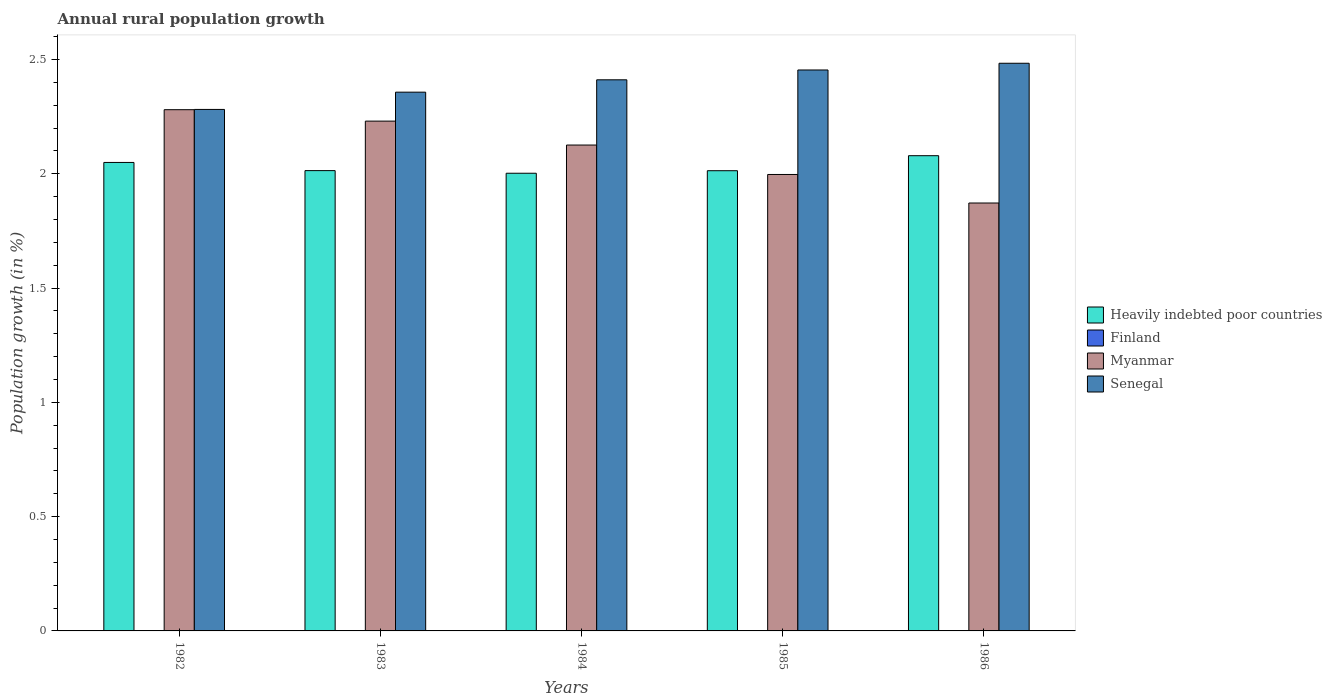How many different coloured bars are there?
Offer a terse response. 3. How many groups of bars are there?
Provide a short and direct response. 5. Are the number of bars per tick equal to the number of legend labels?
Provide a succinct answer. No. How many bars are there on the 2nd tick from the left?
Ensure brevity in your answer.  3. How many bars are there on the 1st tick from the right?
Make the answer very short. 3. What is the label of the 3rd group of bars from the left?
Your answer should be compact. 1984. In how many cases, is the number of bars for a given year not equal to the number of legend labels?
Make the answer very short. 5. What is the percentage of rural population growth in Heavily indebted poor countries in 1983?
Keep it short and to the point. 2.01. Across all years, what is the maximum percentage of rural population growth in Senegal?
Your response must be concise. 2.48. Across all years, what is the minimum percentage of rural population growth in Senegal?
Provide a short and direct response. 2.28. In which year was the percentage of rural population growth in Myanmar maximum?
Make the answer very short. 1982. What is the total percentage of rural population growth in Heavily indebted poor countries in the graph?
Your answer should be very brief. 10.16. What is the difference between the percentage of rural population growth in Myanmar in 1982 and that in 1984?
Keep it short and to the point. 0.15. What is the difference between the percentage of rural population growth in Senegal in 1982 and the percentage of rural population growth in Finland in 1983?
Offer a terse response. 2.28. What is the average percentage of rural population growth in Heavily indebted poor countries per year?
Your answer should be compact. 2.03. In the year 1983, what is the difference between the percentage of rural population growth in Heavily indebted poor countries and percentage of rural population growth in Senegal?
Make the answer very short. -0.34. What is the ratio of the percentage of rural population growth in Myanmar in 1984 to that in 1985?
Keep it short and to the point. 1.06. Is the percentage of rural population growth in Heavily indebted poor countries in 1983 less than that in 1985?
Your answer should be compact. No. Is the difference between the percentage of rural population growth in Heavily indebted poor countries in 1982 and 1984 greater than the difference between the percentage of rural population growth in Senegal in 1982 and 1984?
Ensure brevity in your answer.  Yes. What is the difference between the highest and the second highest percentage of rural population growth in Heavily indebted poor countries?
Your answer should be compact. 0.03. What is the difference between the highest and the lowest percentage of rural population growth in Myanmar?
Your answer should be compact. 0.41. Is the sum of the percentage of rural population growth in Myanmar in 1982 and 1983 greater than the maximum percentage of rural population growth in Heavily indebted poor countries across all years?
Ensure brevity in your answer.  Yes. Is it the case that in every year, the sum of the percentage of rural population growth in Heavily indebted poor countries and percentage of rural population growth in Senegal is greater than the sum of percentage of rural population growth in Finland and percentage of rural population growth in Myanmar?
Keep it short and to the point. No. How many bars are there?
Offer a terse response. 15. Are all the bars in the graph horizontal?
Provide a succinct answer. No. Does the graph contain grids?
Make the answer very short. No. Where does the legend appear in the graph?
Your response must be concise. Center right. How are the legend labels stacked?
Make the answer very short. Vertical. What is the title of the graph?
Your answer should be very brief. Annual rural population growth. Does "Sweden" appear as one of the legend labels in the graph?
Provide a short and direct response. No. What is the label or title of the Y-axis?
Your response must be concise. Population growth (in %). What is the Population growth (in %) of Heavily indebted poor countries in 1982?
Give a very brief answer. 2.05. What is the Population growth (in %) of Myanmar in 1982?
Keep it short and to the point. 2.28. What is the Population growth (in %) of Senegal in 1982?
Keep it short and to the point. 2.28. What is the Population growth (in %) of Heavily indebted poor countries in 1983?
Ensure brevity in your answer.  2.01. What is the Population growth (in %) in Myanmar in 1983?
Provide a short and direct response. 2.23. What is the Population growth (in %) in Senegal in 1983?
Make the answer very short. 2.36. What is the Population growth (in %) of Heavily indebted poor countries in 1984?
Provide a short and direct response. 2. What is the Population growth (in %) of Finland in 1984?
Give a very brief answer. 0. What is the Population growth (in %) in Myanmar in 1984?
Your answer should be very brief. 2.13. What is the Population growth (in %) in Senegal in 1984?
Offer a terse response. 2.41. What is the Population growth (in %) in Heavily indebted poor countries in 1985?
Provide a short and direct response. 2.01. What is the Population growth (in %) of Myanmar in 1985?
Keep it short and to the point. 2. What is the Population growth (in %) in Senegal in 1985?
Your answer should be compact. 2.45. What is the Population growth (in %) of Heavily indebted poor countries in 1986?
Provide a short and direct response. 2.08. What is the Population growth (in %) in Myanmar in 1986?
Offer a terse response. 1.87. What is the Population growth (in %) of Senegal in 1986?
Your response must be concise. 2.48. Across all years, what is the maximum Population growth (in %) in Heavily indebted poor countries?
Keep it short and to the point. 2.08. Across all years, what is the maximum Population growth (in %) in Myanmar?
Provide a short and direct response. 2.28. Across all years, what is the maximum Population growth (in %) of Senegal?
Your response must be concise. 2.48. Across all years, what is the minimum Population growth (in %) in Heavily indebted poor countries?
Offer a very short reply. 2. Across all years, what is the minimum Population growth (in %) of Myanmar?
Offer a terse response. 1.87. Across all years, what is the minimum Population growth (in %) of Senegal?
Your answer should be very brief. 2.28. What is the total Population growth (in %) of Heavily indebted poor countries in the graph?
Your answer should be compact. 10.16. What is the total Population growth (in %) of Myanmar in the graph?
Ensure brevity in your answer.  10.51. What is the total Population growth (in %) of Senegal in the graph?
Your answer should be very brief. 11.99. What is the difference between the Population growth (in %) in Heavily indebted poor countries in 1982 and that in 1983?
Offer a very short reply. 0.04. What is the difference between the Population growth (in %) in Myanmar in 1982 and that in 1983?
Offer a very short reply. 0.05. What is the difference between the Population growth (in %) in Senegal in 1982 and that in 1983?
Your answer should be very brief. -0.08. What is the difference between the Population growth (in %) in Heavily indebted poor countries in 1982 and that in 1984?
Give a very brief answer. 0.05. What is the difference between the Population growth (in %) of Myanmar in 1982 and that in 1984?
Provide a short and direct response. 0.15. What is the difference between the Population growth (in %) in Senegal in 1982 and that in 1984?
Your answer should be very brief. -0.13. What is the difference between the Population growth (in %) in Heavily indebted poor countries in 1982 and that in 1985?
Your answer should be very brief. 0.04. What is the difference between the Population growth (in %) of Myanmar in 1982 and that in 1985?
Provide a succinct answer. 0.28. What is the difference between the Population growth (in %) of Senegal in 1982 and that in 1985?
Your answer should be very brief. -0.17. What is the difference between the Population growth (in %) in Heavily indebted poor countries in 1982 and that in 1986?
Ensure brevity in your answer.  -0.03. What is the difference between the Population growth (in %) of Myanmar in 1982 and that in 1986?
Your response must be concise. 0.41. What is the difference between the Population growth (in %) of Senegal in 1982 and that in 1986?
Your answer should be very brief. -0.2. What is the difference between the Population growth (in %) in Heavily indebted poor countries in 1983 and that in 1984?
Your answer should be compact. 0.01. What is the difference between the Population growth (in %) in Myanmar in 1983 and that in 1984?
Provide a short and direct response. 0.1. What is the difference between the Population growth (in %) in Senegal in 1983 and that in 1984?
Your answer should be compact. -0.05. What is the difference between the Population growth (in %) of Heavily indebted poor countries in 1983 and that in 1985?
Give a very brief answer. 0. What is the difference between the Population growth (in %) in Myanmar in 1983 and that in 1985?
Keep it short and to the point. 0.23. What is the difference between the Population growth (in %) of Senegal in 1983 and that in 1985?
Give a very brief answer. -0.1. What is the difference between the Population growth (in %) of Heavily indebted poor countries in 1983 and that in 1986?
Make the answer very short. -0.07. What is the difference between the Population growth (in %) of Myanmar in 1983 and that in 1986?
Offer a terse response. 0.36. What is the difference between the Population growth (in %) in Senegal in 1983 and that in 1986?
Provide a short and direct response. -0.13. What is the difference between the Population growth (in %) of Heavily indebted poor countries in 1984 and that in 1985?
Provide a short and direct response. -0.01. What is the difference between the Population growth (in %) in Myanmar in 1984 and that in 1985?
Ensure brevity in your answer.  0.13. What is the difference between the Population growth (in %) of Senegal in 1984 and that in 1985?
Give a very brief answer. -0.04. What is the difference between the Population growth (in %) in Heavily indebted poor countries in 1984 and that in 1986?
Provide a short and direct response. -0.08. What is the difference between the Population growth (in %) in Myanmar in 1984 and that in 1986?
Offer a very short reply. 0.25. What is the difference between the Population growth (in %) of Senegal in 1984 and that in 1986?
Ensure brevity in your answer.  -0.07. What is the difference between the Population growth (in %) in Heavily indebted poor countries in 1985 and that in 1986?
Provide a short and direct response. -0.07. What is the difference between the Population growth (in %) of Myanmar in 1985 and that in 1986?
Provide a short and direct response. 0.12. What is the difference between the Population growth (in %) of Senegal in 1985 and that in 1986?
Your response must be concise. -0.03. What is the difference between the Population growth (in %) in Heavily indebted poor countries in 1982 and the Population growth (in %) in Myanmar in 1983?
Make the answer very short. -0.18. What is the difference between the Population growth (in %) in Heavily indebted poor countries in 1982 and the Population growth (in %) in Senegal in 1983?
Offer a terse response. -0.31. What is the difference between the Population growth (in %) in Myanmar in 1982 and the Population growth (in %) in Senegal in 1983?
Your answer should be compact. -0.08. What is the difference between the Population growth (in %) in Heavily indebted poor countries in 1982 and the Population growth (in %) in Myanmar in 1984?
Provide a succinct answer. -0.08. What is the difference between the Population growth (in %) in Heavily indebted poor countries in 1982 and the Population growth (in %) in Senegal in 1984?
Your answer should be very brief. -0.36. What is the difference between the Population growth (in %) in Myanmar in 1982 and the Population growth (in %) in Senegal in 1984?
Offer a terse response. -0.13. What is the difference between the Population growth (in %) of Heavily indebted poor countries in 1982 and the Population growth (in %) of Myanmar in 1985?
Make the answer very short. 0.05. What is the difference between the Population growth (in %) of Heavily indebted poor countries in 1982 and the Population growth (in %) of Senegal in 1985?
Give a very brief answer. -0.4. What is the difference between the Population growth (in %) in Myanmar in 1982 and the Population growth (in %) in Senegal in 1985?
Give a very brief answer. -0.17. What is the difference between the Population growth (in %) of Heavily indebted poor countries in 1982 and the Population growth (in %) of Myanmar in 1986?
Your answer should be very brief. 0.18. What is the difference between the Population growth (in %) in Heavily indebted poor countries in 1982 and the Population growth (in %) in Senegal in 1986?
Provide a succinct answer. -0.43. What is the difference between the Population growth (in %) of Myanmar in 1982 and the Population growth (in %) of Senegal in 1986?
Offer a very short reply. -0.2. What is the difference between the Population growth (in %) of Heavily indebted poor countries in 1983 and the Population growth (in %) of Myanmar in 1984?
Provide a succinct answer. -0.11. What is the difference between the Population growth (in %) of Heavily indebted poor countries in 1983 and the Population growth (in %) of Senegal in 1984?
Make the answer very short. -0.4. What is the difference between the Population growth (in %) of Myanmar in 1983 and the Population growth (in %) of Senegal in 1984?
Keep it short and to the point. -0.18. What is the difference between the Population growth (in %) in Heavily indebted poor countries in 1983 and the Population growth (in %) in Myanmar in 1985?
Your answer should be compact. 0.02. What is the difference between the Population growth (in %) in Heavily indebted poor countries in 1983 and the Population growth (in %) in Senegal in 1985?
Make the answer very short. -0.44. What is the difference between the Population growth (in %) in Myanmar in 1983 and the Population growth (in %) in Senegal in 1985?
Make the answer very short. -0.22. What is the difference between the Population growth (in %) of Heavily indebted poor countries in 1983 and the Population growth (in %) of Myanmar in 1986?
Your answer should be compact. 0.14. What is the difference between the Population growth (in %) in Heavily indebted poor countries in 1983 and the Population growth (in %) in Senegal in 1986?
Keep it short and to the point. -0.47. What is the difference between the Population growth (in %) in Myanmar in 1983 and the Population growth (in %) in Senegal in 1986?
Provide a short and direct response. -0.25. What is the difference between the Population growth (in %) in Heavily indebted poor countries in 1984 and the Population growth (in %) in Myanmar in 1985?
Provide a short and direct response. 0.01. What is the difference between the Population growth (in %) of Heavily indebted poor countries in 1984 and the Population growth (in %) of Senegal in 1985?
Your answer should be very brief. -0.45. What is the difference between the Population growth (in %) of Myanmar in 1984 and the Population growth (in %) of Senegal in 1985?
Give a very brief answer. -0.33. What is the difference between the Population growth (in %) of Heavily indebted poor countries in 1984 and the Population growth (in %) of Myanmar in 1986?
Keep it short and to the point. 0.13. What is the difference between the Population growth (in %) of Heavily indebted poor countries in 1984 and the Population growth (in %) of Senegal in 1986?
Provide a short and direct response. -0.48. What is the difference between the Population growth (in %) in Myanmar in 1984 and the Population growth (in %) in Senegal in 1986?
Your answer should be compact. -0.36. What is the difference between the Population growth (in %) in Heavily indebted poor countries in 1985 and the Population growth (in %) in Myanmar in 1986?
Make the answer very short. 0.14. What is the difference between the Population growth (in %) in Heavily indebted poor countries in 1985 and the Population growth (in %) in Senegal in 1986?
Your answer should be very brief. -0.47. What is the difference between the Population growth (in %) in Myanmar in 1985 and the Population growth (in %) in Senegal in 1986?
Keep it short and to the point. -0.49. What is the average Population growth (in %) in Heavily indebted poor countries per year?
Offer a terse response. 2.03. What is the average Population growth (in %) of Finland per year?
Make the answer very short. 0. What is the average Population growth (in %) in Myanmar per year?
Your answer should be compact. 2.1. What is the average Population growth (in %) of Senegal per year?
Give a very brief answer. 2.4. In the year 1982, what is the difference between the Population growth (in %) in Heavily indebted poor countries and Population growth (in %) in Myanmar?
Offer a very short reply. -0.23. In the year 1982, what is the difference between the Population growth (in %) of Heavily indebted poor countries and Population growth (in %) of Senegal?
Ensure brevity in your answer.  -0.23. In the year 1982, what is the difference between the Population growth (in %) in Myanmar and Population growth (in %) in Senegal?
Ensure brevity in your answer.  -0. In the year 1983, what is the difference between the Population growth (in %) in Heavily indebted poor countries and Population growth (in %) in Myanmar?
Provide a short and direct response. -0.22. In the year 1983, what is the difference between the Population growth (in %) in Heavily indebted poor countries and Population growth (in %) in Senegal?
Ensure brevity in your answer.  -0.34. In the year 1983, what is the difference between the Population growth (in %) in Myanmar and Population growth (in %) in Senegal?
Your answer should be very brief. -0.13. In the year 1984, what is the difference between the Population growth (in %) in Heavily indebted poor countries and Population growth (in %) in Myanmar?
Your response must be concise. -0.12. In the year 1984, what is the difference between the Population growth (in %) of Heavily indebted poor countries and Population growth (in %) of Senegal?
Offer a terse response. -0.41. In the year 1984, what is the difference between the Population growth (in %) of Myanmar and Population growth (in %) of Senegal?
Provide a short and direct response. -0.29. In the year 1985, what is the difference between the Population growth (in %) in Heavily indebted poor countries and Population growth (in %) in Myanmar?
Offer a very short reply. 0.02. In the year 1985, what is the difference between the Population growth (in %) in Heavily indebted poor countries and Population growth (in %) in Senegal?
Give a very brief answer. -0.44. In the year 1985, what is the difference between the Population growth (in %) in Myanmar and Population growth (in %) in Senegal?
Make the answer very short. -0.46. In the year 1986, what is the difference between the Population growth (in %) of Heavily indebted poor countries and Population growth (in %) of Myanmar?
Provide a succinct answer. 0.21. In the year 1986, what is the difference between the Population growth (in %) in Heavily indebted poor countries and Population growth (in %) in Senegal?
Provide a succinct answer. -0.4. In the year 1986, what is the difference between the Population growth (in %) in Myanmar and Population growth (in %) in Senegal?
Give a very brief answer. -0.61. What is the ratio of the Population growth (in %) in Heavily indebted poor countries in 1982 to that in 1983?
Give a very brief answer. 1.02. What is the ratio of the Population growth (in %) in Myanmar in 1982 to that in 1983?
Provide a succinct answer. 1.02. What is the ratio of the Population growth (in %) in Senegal in 1982 to that in 1983?
Your answer should be compact. 0.97. What is the ratio of the Population growth (in %) in Heavily indebted poor countries in 1982 to that in 1984?
Give a very brief answer. 1.02. What is the ratio of the Population growth (in %) in Myanmar in 1982 to that in 1984?
Offer a very short reply. 1.07. What is the ratio of the Population growth (in %) of Senegal in 1982 to that in 1984?
Your response must be concise. 0.95. What is the ratio of the Population growth (in %) in Myanmar in 1982 to that in 1985?
Provide a succinct answer. 1.14. What is the ratio of the Population growth (in %) in Senegal in 1982 to that in 1985?
Offer a terse response. 0.93. What is the ratio of the Population growth (in %) of Heavily indebted poor countries in 1982 to that in 1986?
Ensure brevity in your answer.  0.99. What is the ratio of the Population growth (in %) in Myanmar in 1982 to that in 1986?
Offer a very short reply. 1.22. What is the ratio of the Population growth (in %) in Senegal in 1982 to that in 1986?
Give a very brief answer. 0.92. What is the ratio of the Population growth (in %) of Heavily indebted poor countries in 1983 to that in 1984?
Keep it short and to the point. 1.01. What is the ratio of the Population growth (in %) of Myanmar in 1983 to that in 1984?
Your answer should be compact. 1.05. What is the ratio of the Population growth (in %) in Senegal in 1983 to that in 1984?
Provide a short and direct response. 0.98. What is the ratio of the Population growth (in %) of Heavily indebted poor countries in 1983 to that in 1985?
Your answer should be compact. 1. What is the ratio of the Population growth (in %) in Myanmar in 1983 to that in 1985?
Your answer should be very brief. 1.12. What is the ratio of the Population growth (in %) of Senegal in 1983 to that in 1985?
Provide a short and direct response. 0.96. What is the ratio of the Population growth (in %) in Heavily indebted poor countries in 1983 to that in 1986?
Give a very brief answer. 0.97. What is the ratio of the Population growth (in %) of Myanmar in 1983 to that in 1986?
Provide a short and direct response. 1.19. What is the ratio of the Population growth (in %) in Senegal in 1983 to that in 1986?
Your answer should be compact. 0.95. What is the ratio of the Population growth (in %) of Myanmar in 1984 to that in 1985?
Provide a short and direct response. 1.06. What is the ratio of the Population growth (in %) of Senegal in 1984 to that in 1985?
Your answer should be compact. 0.98. What is the ratio of the Population growth (in %) of Heavily indebted poor countries in 1984 to that in 1986?
Your answer should be compact. 0.96. What is the ratio of the Population growth (in %) of Myanmar in 1984 to that in 1986?
Your answer should be very brief. 1.14. What is the ratio of the Population growth (in %) in Senegal in 1984 to that in 1986?
Keep it short and to the point. 0.97. What is the ratio of the Population growth (in %) in Heavily indebted poor countries in 1985 to that in 1986?
Your answer should be very brief. 0.97. What is the ratio of the Population growth (in %) of Myanmar in 1985 to that in 1986?
Offer a very short reply. 1.07. What is the difference between the highest and the second highest Population growth (in %) of Heavily indebted poor countries?
Provide a succinct answer. 0.03. What is the difference between the highest and the second highest Population growth (in %) in Senegal?
Provide a short and direct response. 0.03. What is the difference between the highest and the lowest Population growth (in %) of Heavily indebted poor countries?
Provide a short and direct response. 0.08. What is the difference between the highest and the lowest Population growth (in %) in Myanmar?
Ensure brevity in your answer.  0.41. What is the difference between the highest and the lowest Population growth (in %) in Senegal?
Provide a short and direct response. 0.2. 